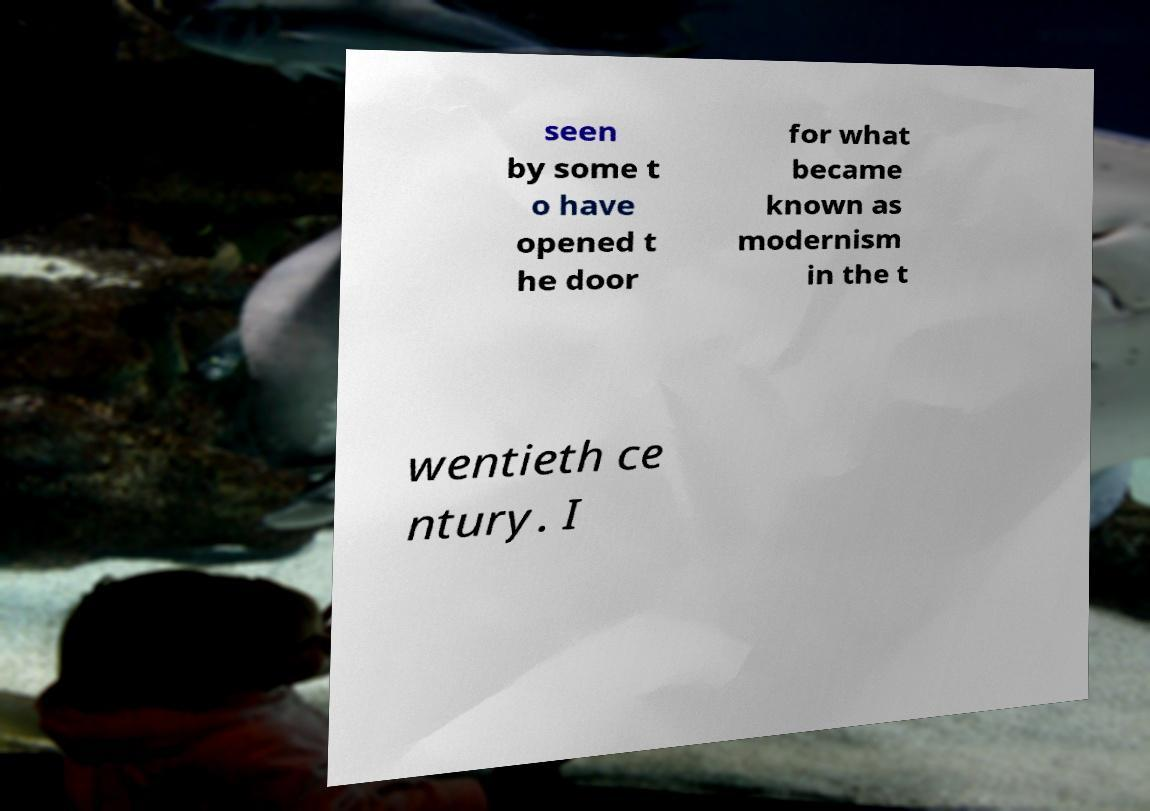For documentation purposes, I need the text within this image transcribed. Could you provide that? seen by some t o have opened t he door for what became known as modernism in the t wentieth ce ntury. I 